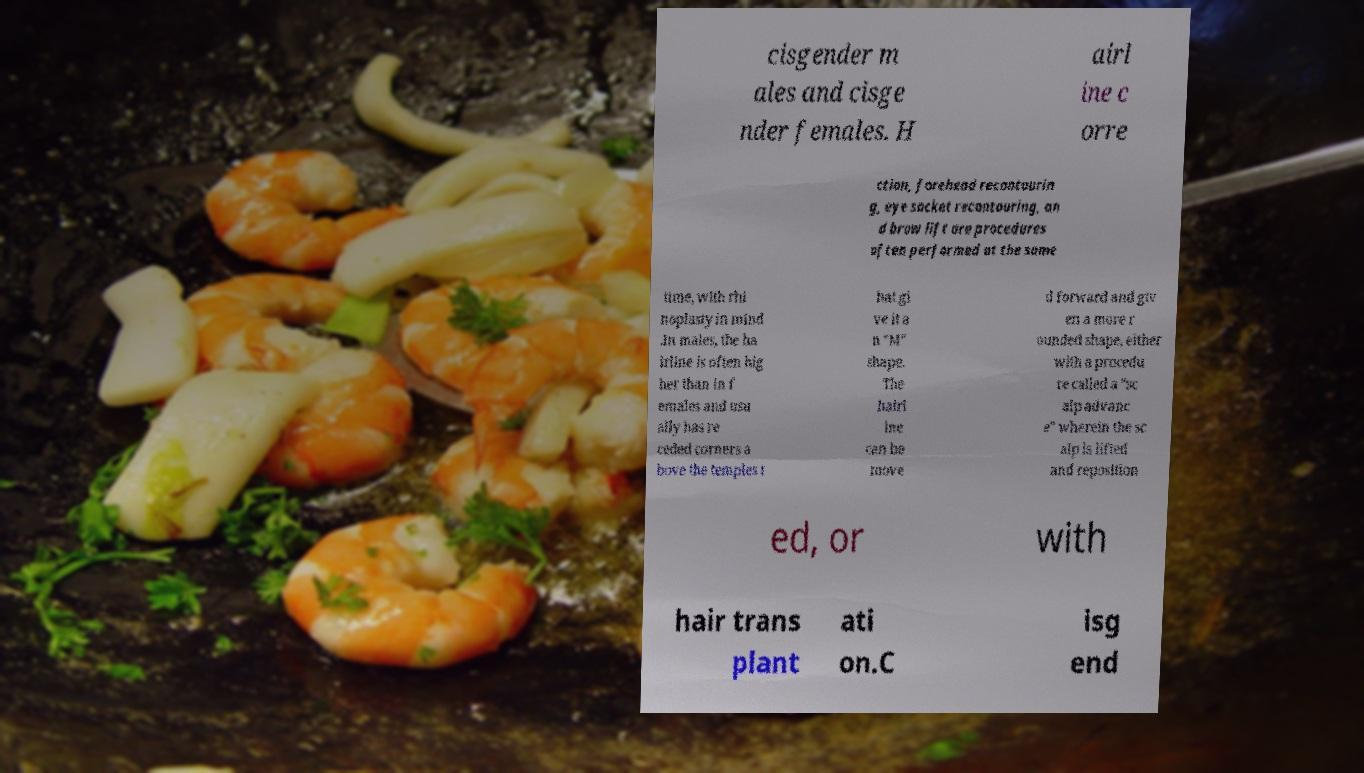Please read and relay the text visible in this image. What does it say? cisgender m ales and cisge nder females. H airl ine c orre ction, forehead recontourin g, eye socket recontouring, an d brow lift are procedures often performed at the same time, with rhi noplasty in mind .In males, the ha irline is often hig her than in f emales and usu ally has re ceded corners a bove the temples t hat gi ve it a n "M" shape. The hairl ine can be move d forward and giv en a more r ounded shape, either with a procedu re called a "sc alp advanc e" wherein the sc alp is lifted and reposition ed, or with hair trans plant ati on.C isg end 